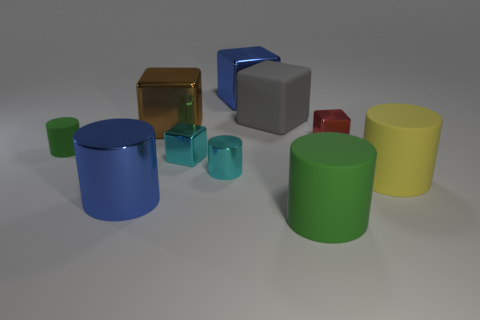The tiny red object that is the same material as the brown object is what shape? The tiny red object, appearing to be made of the same glossy material as the larger brown cube, is itself a cube, characterized by its six faces, each of which is a square. 